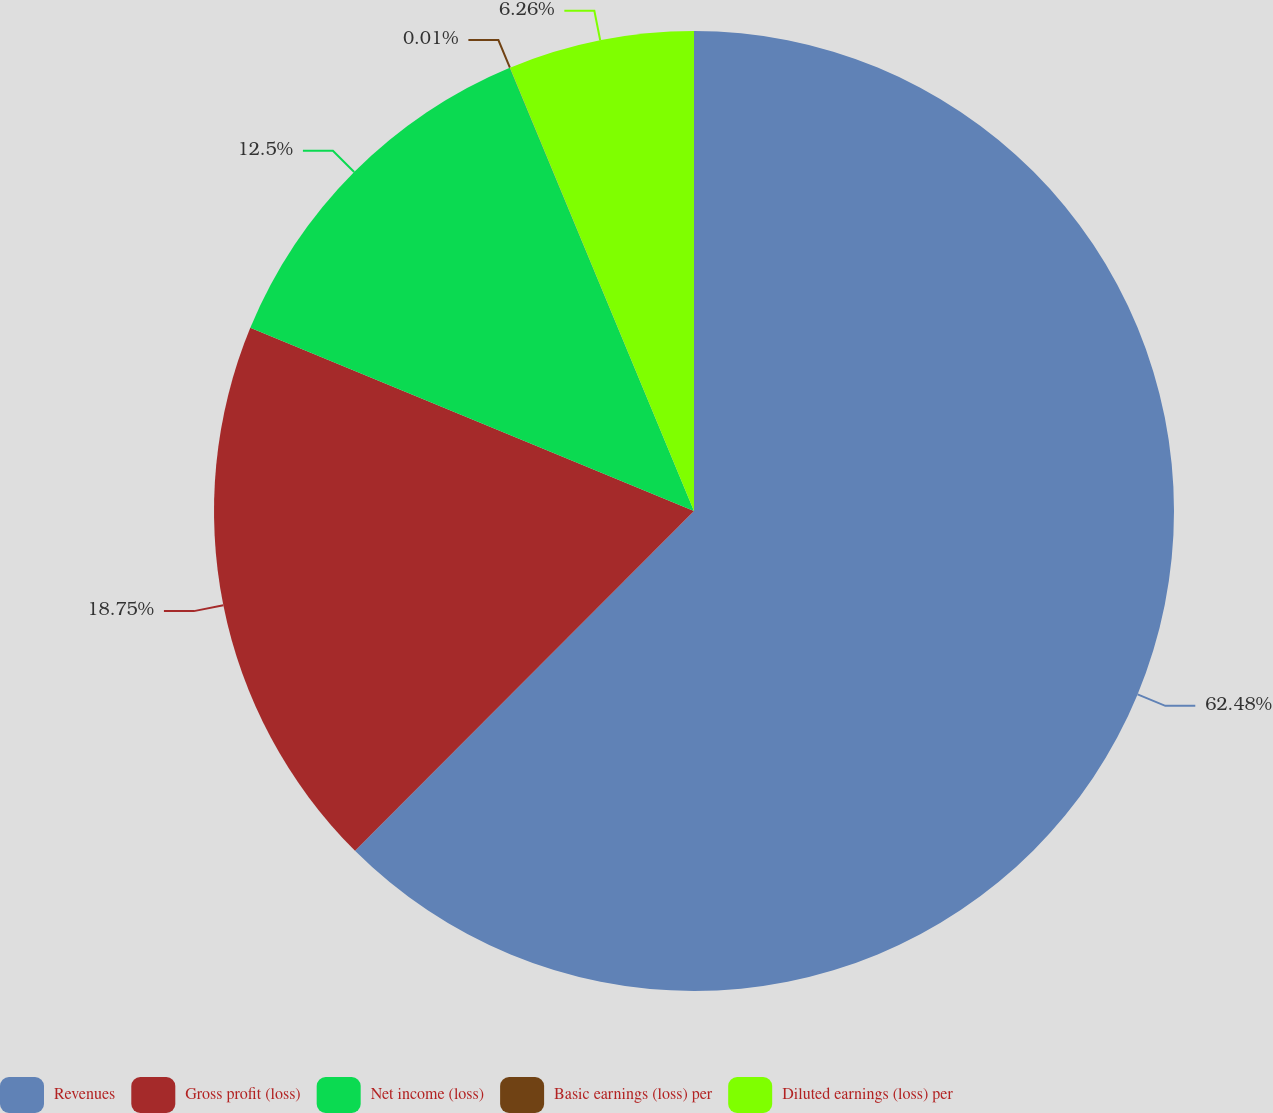<chart> <loc_0><loc_0><loc_500><loc_500><pie_chart><fcel>Revenues<fcel>Gross profit (loss)<fcel>Net income (loss)<fcel>Basic earnings (loss) per<fcel>Diluted earnings (loss) per<nl><fcel>62.48%<fcel>18.75%<fcel>12.5%<fcel>0.01%<fcel>6.26%<nl></chart> 